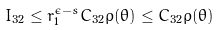<formula> <loc_0><loc_0><loc_500><loc_500>I _ { 3 2 } \leq r _ { 1 } ^ { \epsilon - s } C _ { 3 2 } \rho ( \theta ) \leq C _ { 3 2 } \rho ( \theta )</formula> 